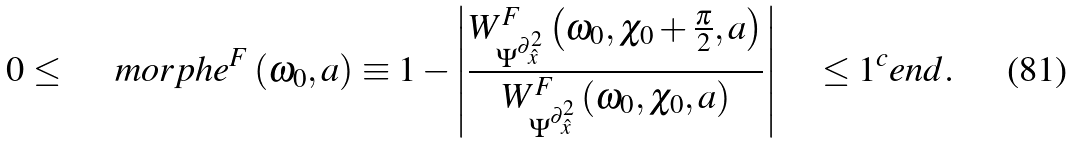Convert formula to latex. <formula><loc_0><loc_0><loc_500><loc_500>0 \leq \quad \ m o r p h e ^ { F } \left ( \omega _ { 0 } , a \right ) \equiv 1 - \left | \frac { W _ { \Psi ^ { \partial _ { \hat { x } } ^ { 2 } } } ^ { F } \left ( \omega _ { 0 } , \chi _ { 0 } + \frac { \pi } { 2 } , a \right ) } { W _ { \Psi ^ { \partial _ { \hat { x } } ^ { 2 } } } ^ { F } \left ( \omega _ { 0 } , \chi _ { 0 } , a \right ) } \right | \quad \leq 1 ^ { c } e n d .</formula> 